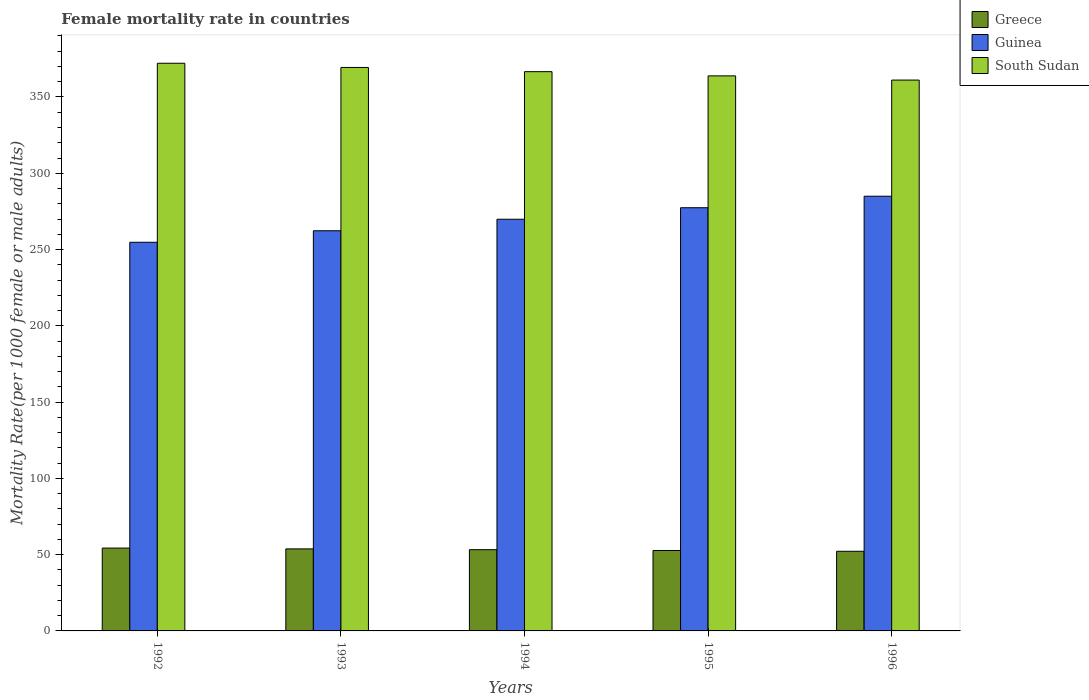Are the number of bars per tick equal to the number of legend labels?
Keep it short and to the point. Yes. Are the number of bars on each tick of the X-axis equal?
Offer a terse response. Yes. How many bars are there on the 2nd tick from the right?
Provide a short and direct response. 3. What is the label of the 3rd group of bars from the left?
Provide a succinct answer. 1994. What is the female mortality rate in Guinea in 1994?
Your response must be concise. 269.85. Across all years, what is the maximum female mortality rate in South Sudan?
Offer a terse response. 372.11. Across all years, what is the minimum female mortality rate in Guinea?
Your answer should be very brief. 254.76. What is the total female mortality rate in South Sudan in the graph?
Ensure brevity in your answer.  1832.97. What is the difference between the female mortality rate in Greece in 1994 and that in 1996?
Give a very brief answer. 1.05. What is the difference between the female mortality rate in South Sudan in 1994 and the female mortality rate in Guinea in 1995?
Your answer should be compact. 89.19. What is the average female mortality rate in Guinea per year?
Offer a terse response. 269.85. In the year 1994, what is the difference between the female mortality rate in Greece and female mortality rate in South Sudan?
Keep it short and to the point. -313.34. In how many years, is the female mortality rate in Greece greater than 310?
Your answer should be compact. 0. What is the ratio of the female mortality rate in Greece in 1993 to that in 1994?
Provide a succinct answer. 1.01. Is the female mortality rate in Guinea in 1993 less than that in 1995?
Make the answer very short. Yes. What is the difference between the highest and the second highest female mortality rate in South Sudan?
Ensure brevity in your answer.  2.76. What is the difference between the highest and the lowest female mortality rate in Greece?
Ensure brevity in your answer.  2.1. In how many years, is the female mortality rate in South Sudan greater than the average female mortality rate in South Sudan taken over all years?
Offer a terse response. 3. Is the sum of the female mortality rate in South Sudan in 1993 and 1996 greater than the maximum female mortality rate in Guinea across all years?
Your answer should be very brief. Yes. What does the 2nd bar from the left in 1992 represents?
Give a very brief answer. Guinea. What does the 3rd bar from the right in 1995 represents?
Make the answer very short. Greece. How many bars are there?
Your response must be concise. 15. Are all the bars in the graph horizontal?
Offer a terse response. No. How many years are there in the graph?
Make the answer very short. 5. What is the difference between two consecutive major ticks on the Y-axis?
Your answer should be very brief. 50. Where does the legend appear in the graph?
Offer a very short reply. Top right. What is the title of the graph?
Your response must be concise. Female mortality rate in countries. Does "Ethiopia" appear as one of the legend labels in the graph?
Keep it short and to the point. No. What is the label or title of the X-axis?
Your answer should be compact. Years. What is the label or title of the Y-axis?
Your answer should be very brief. Mortality Rate(per 1000 female or male adults). What is the Mortality Rate(per 1000 female or male adults) in Greece in 1992?
Your response must be concise. 54.31. What is the Mortality Rate(per 1000 female or male adults) of Guinea in 1992?
Your response must be concise. 254.76. What is the Mortality Rate(per 1000 female or male adults) of South Sudan in 1992?
Ensure brevity in your answer.  372.11. What is the Mortality Rate(per 1000 female or male adults) in Greece in 1993?
Make the answer very short. 53.78. What is the Mortality Rate(per 1000 female or male adults) of Guinea in 1993?
Provide a short and direct response. 262.31. What is the Mortality Rate(per 1000 female or male adults) in South Sudan in 1993?
Your response must be concise. 369.35. What is the Mortality Rate(per 1000 female or male adults) in Greece in 1994?
Provide a short and direct response. 53.26. What is the Mortality Rate(per 1000 female or male adults) of Guinea in 1994?
Ensure brevity in your answer.  269.85. What is the Mortality Rate(per 1000 female or male adults) in South Sudan in 1994?
Your answer should be very brief. 366.59. What is the Mortality Rate(per 1000 female or male adults) in Greece in 1995?
Your answer should be very brief. 52.73. What is the Mortality Rate(per 1000 female or male adults) in Guinea in 1995?
Your answer should be very brief. 277.4. What is the Mortality Rate(per 1000 female or male adults) in South Sudan in 1995?
Your response must be concise. 363.84. What is the Mortality Rate(per 1000 female or male adults) of Greece in 1996?
Your answer should be very brief. 52.21. What is the Mortality Rate(per 1000 female or male adults) of Guinea in 1996?
Your answer should be very brief. 284.95. What is the Mortality Rate(per 1000 female or male adults) of South Sudan in 1996?
Your response must be concise. 361.08. Across all years, what is the maximum Mortality Rate(per 1000 female or male adults) of Greece?
Keep it short and to the point. 54.31. Across all years, what is the maximum Mortality Rate(per 1000 female or male adults) of Guinea?
Make the answer very short. 284.95. Across all years, what is the maximum Mortality Rate(per 1000 female or male adults) in South Sudan?
Ensure brevity in your answer.  372.11. Across all years, what is the minimum Mortality Rate(per 1000 female or male adults) of Greece?
Your answer should be compact. 52.21. Across all years, what is the minimum Mortality Rate(per 1000 female or male adults) of Guinea?
Offer a very short reply. 254.76. Across all years, what is the minimum Mortality Rate(per 1000 female or male adults) in South Sudan?
Your response must be concise. 361.08. What is the total Mortality Rate(per 1000 female or male adults) in Greece in the graph?
Offer a terse response. 266.28. What is the total Mortality Rate(per 1000 female or male adults) of Guinea in the graph?
Keep it short and to the point. 1349.27. What is the total Mortality Rate(per 1000 female or male adults) in South Sudan in the graph?
Ensure brevity in your answer.  1832.97. What is the difference between the Mortality Rate(per 1000 female or male adults) in Greece in 1992 and that in 1993?
Keep it short and to the point. 0.53. What is the difference between the Mortality Rate(per 1000 female or male adults) in Guinea in 1992 and that in 1993?
Your answer should be compact. -7.55. What is the difference between the Mortality Rate(per 1000 female or male adults) in South Sudan in 1992 and that in 1993?
Keep it short and to the point. 2.76. What is the difference between the Mortality Rate(per 1000 female or male adults) of Greece in 1992 and that in 1994?
Give a very brief answer. 1.05. What is the difference between the Mortality Rate(per 1000 female or male adults) of Guinea in 1992 and that in 1994?
Your answer should be compact. -15.1. What is the difference between the Mortality Rate(per 1000 female or male adults) of South Sudan in 1992 and that in 1994?
Your response must be concise. 5.51. What is the difference between the Mortality Rate(per 1000 female or male adults) in Greece in 1992 and that in 1995?
Make the answer very short. 1.57. What is the difference between the Mortality Rate(per 1000 female or male adults) in Guinea in 1992 and that in 1995?
Offer a terse response. -22.65. What is the difference between the Mortality Rate(per 1000 female or male adults) in South Sudan in 1992 and that in 1995?
Your response must be concise. 8.27. What is the difference between the Mortality Rate(per 1000 female or male adults) in Greece in 1992 and that in 1996?
Keep it short and to the point. 2.1. What is the difference between the Mortality Rate(per 1000 female or male adults) of Guinea in 1992 and that in 1996?
Your response must be concise. -30.19. What is the difference between the Mortality Rate(per 1000 female or male adults) in South Sudan in 1992 and that in 1996?
Provide a short and direct response. 11.02. What is the difference between the Mortality Rate(per 1000 female or male adults) in Greece in 1993 and that in 1994?
Ensure brevity in your answer.  0.53. What is the difference between the Mortality Rate(per 1000 female or male adults) of Guinea in 1993 and that in 1994?
Offer a terse response. -7.55. What is the difference between the Mortality Rate(per 1000 female or male adults) in South Sudan in 1993 and that in 1994?
Provide a succinct answer. 2.76. What is the difference between the Mortality Rate(per 1000 female or male adults) in Greece in 1993 and that in 1995?
Make the answer very short. 1.05. What is the difference between the Mortality Rate(per 1000 female or male adults) of Guinea in 1993 and that in 1995?
Offer a terse response. -15.1. What is the difference between the Mortality Rate(per 1000 female or male adults) of South Sudan in 1993 and that in 1995?
Your response must be concise. 5.51. What is the difference between the Mortality Rate(per 1000 female or male adults) in Greece in 1993 and that in 1996?
Your answer should be compact. 1.57. What is the difference between the Mortality Rate(per 1000 female or male adults) of Guinea in 1993 and that in 1996?
Offer a very short reply. -22.64. What is the difference between the Mortality Rate(per 1000 female or male adults) of South Sudan in 1993 and that in 1996?
Make the answer very short. 8.27. What is the difference between the Mortality Rate(per 1000 female or male adults) in Greece in 1994 and that in 1995?
Your answer should be compact. 0.53. What is the difference between the Mortality Rate(per 1000 female or male adults) in Guinea in 1994 and that in 1995?
Your answer should be compact. -7.55. What is the difference between the Mortality Rate(per 1000 female or male adults) of South Sudan in 1994 and that in 1995?
Your answer should be compact. 2.76. What is the difference between the Mortality Rate(per 1000 female or male adults) in Greece in 1994 and that in 1996?
Give a very brief answer. 1.05. What is the difference between the Mortality Rate(per 1000 female or male adults) in Guinea in 1994 and that in 1996?
Your answer should be very brief. -15.1. What is the difference between the Mortality Rate(per 1000 female or male adults) in South Sudan in 1994 and that in 1996?
Keep it short and to the point. 5.51. What is the difference between the Mortality Rate(per 1000 female or male adults) of Greece in 1995 and that in 1996?
Provide a succinct answer. 0.53. What is the difference between the Mortality Rate(per 1000 female or male adults) in Guinea in 1995 and that in 1996?
Keep it short and to the point. -7.55. What is the difference between the Mortality Rate(per 1000 female or male adults) of South Sudan in 1995 and that in 1996?
Offer a terse response. 2.76. What is the difference between the Mortality Rate(per 1000 female or male adults) in Greece in 1992 and the Mortality Rate(per 1000 female or male adults) in Guinea in 1993?
Ensure brevity in your answer.  -208. What is the difference between the Mortality Rate(per 1000 female or male adults) of Greece in 1992 and the Mortality Rate(per 1000 female or male adults) of South Sudan in 1993?
Ensure brevity in your answer.  -315.04. What is the difference between the Mortality Rate(per 1000 female or male adults) in Guinea in 1992 and the Mortality Rate(per 1000 female or male adults) in South Sudan in 1993?
Your answer should be compact. -114.59. What is the difference between the Mortality Rate(per 1000 female or male adults) in Greece in 1992 and the Mortality Rate(per 1000 female or male adults) in Guinea in 1994?
Make the answer very short. -215.55. What is the difference between the Mortality Rate(per 1000 female or male adults) in Greece in 1992 and the Mortality Rate(per 1000 female or male adults) in South Sudan in 1994?
Offer a very short reply. -312.29. What is the difference between the Mortality Rate(per 1000 female or male adults) of Guinea in 1992 and the Mortality Rate(per 1000 female or male adults) of South Sudan in 1994?
Ensure brevity in your answer.  -111.84. What is the difference between the Mortality Rate(per 1000 female or male adults) in Greece in 1992 and the Mortality Rate(per 1000 female or male adults) in Guinea in 1995?
Your answer should be compact. -223.1. What is the difference between the Mortality Rate(per 1000 female or male adults) of Greece in 1992 and the Mortality Rate(per 1000 female or male adults) of South Sudan in 1995?
Offer a terse response. -309.53. What is the difference between the Mortality Rate(per 1000 female or male adults) of Guinea in 1992 and the Mortality Rate(per 1000 female or male adults) of South Sudan in 1995?
Your response must be concise. -109.08. What is the difference between the Mortality Rate(per 1000 female or male adults) of Greece in 1992 and the Mortality Rate(per 1000 female or male adults) of Guinea in 1996?
Provide a succinct answer. -230.64. What is the difference between the Mortality Rate(per 1000 female or male adults) in Greece in 1992 and the Mortality Rate(per 1000 female or male adults) in South Sudan in 1996?
Provide a succinct answer. -306.78. What is the difference between the Mortality Rate(per 1000 female or male adults) of Guinea in 1992 and the Mortality Rate(per 1000 female or male adults) of South Sudan in 1996?
Your answer should be very brief. -106.33. What is the difference between the Mortality Rate(per 1000 female or male adults) in Greece in 1993 and the Mortality Rate(per 1000 female or male adults) in Guinea in 1994?
Offer a very short reply. -216.07. What is the difference between the Mortality Rate(per 1000 female or male adults) of Greece in 1993 and the Mortality Rate(per 1000 female or male adults) of South Sudan in 1994?
Your answer should be compact. -312.81. What is the difference between the Mortality Rate(per 1000 female or male adults) of Guinea in 1993 and the Mortality Rate(per 1000 female or male adults) of South Sudan in 1994?
Ensure brevity in your answer.  -104.29. What is the difference between the Mortality Rate(per 1000 female or male adults) of Greece in 1993 and the Mortality Rate(per 1000 female or male adults) of Guinea in 1995?
Your response must be concise. -223.62. What is the difference between the Mortality Rate(per 1000 female or male adults) of Greece in 1993 and the Mortality Rate(per 1000 female or male adults) of South Sudan in 1995?
Keep it short and to the point. -310.06. What is the difference between the Mortality Rate(per 1000 female or male adults) of Guinea in 1993 and the Mortality Rate(per 1000 female or male adults) of South Sudan in 1995?
Keep it short and to the point. -101.53. What is the difference between the Mortality Rate(per 1000 female or male adults) in Greece in 1993 and the Mortality Rate(per 1000 female or male adults) in Guinea in 1996?
Make the answer very short. -231.17. What is the difference between the Mortality Rate(per 1000 female or male adults) of Greece in 1993 and the Mortality Rate(per 1000 female or male adults) of South Sudan in 1996?
Provide a short and direct response. -307.3. What is the difference between the Mortality Rate(per 1000 female or male adults) of Guinea in 1993 and the Mortality Rate(per 1000 female or male adults) of South Sudan in 1996?
Offer a very short reply. -98.78. What is the difference between the Mortality Rate(per 1000 female or male adults) in Greece in 1994 and the Mortality Rate(per 1000 female or male adults) in Guinea in 1995?
Keep it short and to the point. -224.15. What is the difference between the Mortality Rate(per 1000 female or male adults) of Greece in 1994 and the Mortality Rate(per 1000 female or male adults) of South Sudan in 1995?
Provide a succinct answer. -310.58. What is the difference between the Mortality Rate(per 1000 female or male adults) of Guinea in 1994 and the Mortality Rate(per 1000 female or male adults) of South Sudan in 1995?
Give a very brief answer. -93.98. What is the difference between the Mortality Rate(per 1000 female or male adults) in Greece in 1994 and the Mortality Rate(per 1000 female or male adults) in Guinea in 1996?
Ensure brevity in your answer.  -231.69. What is the difference between the Mortality Rate(per 1000 female or male adults) in Greece in 1994 and the Mortality Rate(per 1000 female or male adults) in South Sudan in 1996?
Your answer should be compact. -307.83. What is the difference between the Mortality Rate(per 1000 female or male adults) in Guinea in 1994 and the Mortality Rate(per 1000 female or male adults) in South Sudan in 1996?
Offer a very short reply. -91.23. What is the difference between the Mortality Rate(per 1000 female or male adults) in Greece in 1995 and the Mortality Rate(per 1000 female or male adults) in Guinea in 1996?
Ensure brevity in your answer.  -232.22. What is the difference between the Mortality Rate(per 1000 female or male adults) of Greece in 1995 and the Mortality Rate(per 1000 female or male adults) of South Sudan in 1996?
Make the answer very short. -308.35. What is the difference between the Mortality Rate(per 1000 female or male adults) in Guinea in 1995 and the Mortality Rate(per 1000 female or male adults) in South Sudan in 1996?
Your answer should be very brief. -83.68. What is the average Mortality Rate(per 1000 female or male adults) of Greece per year?
Keep it short and to the point. 53.26. What is the average Mortality Rate(per 1000 female or male adults) in Guinea per year?
Your answer should be very brief. 269.85. What is the average Mortality Rate(per 1000 female or male adults) of South Sudan per year?
Make the answer very short. 366.59. In the year 1992, what is the difference between the Mortality Rate(per 1000 female or male adults) of Greece and Mortality Rate(per 1000 female or male adults) of Guinea?
Give a very brief answer. -200.45. In the year 1992, what is the difference between the Mortality Rate(per 1000 female or male adults) in Greece and Mortality Rate(per 1000 female or male adults) in South Sudan?
Your answer should be very brief. -317.8. In the year 1992, what is the difference between the Mortality Rate(per 1000 female or male adults) in Guinea and Mortality Rate(per 1000 female or male adults) in South Sudan?
Give a very brief answer. -117.35. In the year 1993, what is the difference between the Mortality Rate(per 1000 female or male adults) in Greece and Mortality Rate(per 1000 female or male adults) in Guinea?
Your response must be concise. -208.52. In the year 1993, what is the difference between the Mortality Rate(per 1000 female or male adults) in Greece and Mortality Rate(per 1000 female or male adults) in South Sudan?
Your answer should be compact. -315.57. In the year 1993, what is the difference between the Mortality Rate(per 1000 female or male adults) of Guinea and Mortality Rate(per 1000 female or male adults) of South Sudan?
Ensure brevity in your answer.  -107.05. In the year 1994, what is the difference between the Mortality Rate(per 1000 female or male adults) of Greece and Mortality Rate(per 1000 female or male adults) of Guinea?
Your answer should be compact. -216.6. In the year 1994, what is the difference between the Mortality Rate(per 1000 female or male adults) of Greece and Mortality Rate(per 1000 female or male adults) of South Sudan?
Keep it short and to the point. -313.34. In the year 1994, what is the difference between the Mortality Rate(per 1000 female or male adults) in Guinea and Mortality Rate(per 1000 female or male adults) in South Sudan?
Ensure brevity in your answer.  -96.74. In the year 1995, what is the difference between the Mortality Rate(per 1000 female or male adults) in Greece and Mortality Rate(per 1000 female or male adults) in Guinea?
Your response must be concise. -224.67. In the year 1995, what is the difference between the Mortality Rate(per 1000 female or male adults) in Greece and Mortality Rate(per 1000 female or male adults) in South Sudan?
Give a very brief answer. -311.11. In the year 1995, what is the difference between the Mortality Rate(per 1000 female or male adults) of Guinea and Mortality Rate(per 1000 female or male adults) of South Sudan?
Keep it short and to the point. -86.44. In the year 1996, what is the difference between the Mortality Rate(per 1000 female or male adults) of Greece and Mortality Rate(per 1000 female or male adults) of Guinea?
Keep it short and to the point. -232.74. In the year 1996, what is the difference between the Mortality Rate(per 1000 female or male adults) of Greece and Mortality Rate(per 1000 female or male adults) of South Sudan?
Ensure brevity in your answer.  -308.88. In the year 1996, what is the difference between the Mortality Rate(per 1000 female or male adults) of Guinea and Mortality Rate(per 1000 female or male adults) of South Sudan?
Ensure brevity in your answer.  -76.13. What is the ratio of the Mortality Rate(per 1000 female or male adults) of Greece in 1992 to that in 1993?
Make the answer very short. 1.01. What is the ratio of the Mortality Rate(per 1000 female or male adults) in Guinea in 1992 to that in 1993?
Your answer should be compact. 0.97. What is the ratio of the Mortality Rate(per 1000 female or male adults) in South Sudan in 1992 to that in 1993?
Provide a succinct answer. 1.01. What is the ratio of the Mortality Rate(per 1000 female or male adults) in Greece in 1992 to that in 1994?
Make the answer very short. 1.02. What is the ratio of the Mortality Rate(per 1000 female or male adults) in Guinea in 1992 to that in 1994?
Your answer should be very brief. 0.94. What is the ratio of the Mortality Rate(per 1000 female or male adults) in Greece in 1992 to that in 1995?
Your answer should be compact. 1.03. What is the ratio of the Mortality Rate(per 1000 female or male adults) in Guinea in 1992 to that in 1995?
Your response must be concise. 0.92. What is the ratio of the Mortality Rate(per 1000 female or male adults) in South Sudan in 1992 to that in 1995?
Make the answer very short. 1.02. What is the ratio of the Mortality Rate(per 1000 female or male adults) of Greece in 1992 to that in 1996?
Make the answer very short. 1.04. What is the ratio of the Mortality Rate(per 1000 female or male adults) of Guinea in 1992 to that in 1996?
Provide a succinct answer. 0.89. What is the ratio of the Mortality Rate(per 1000 female or male adults) in South Sudan in 1992 to that in 1996?
Offer a very short reply. 1.03. What is the ratio of the Mortality Rate(per 1000 female or male adults) in Greece in 1993 to that in 1994?
Keep it short and to the point. 1.01. What is the ratio of the Mortality Rate(per 1000 female or male adults) of South Sudan in 1993 to that in 1994?
Your response must be concise. 1.01. What is the ratio of the Mortality Rate(per 1000 female or male adults) of Greece in 1993 to that in 1995?
Your response must be concise. 1.02. What is the ratio of the Mortality Rate(per 1000 female or male adults) in Guinea in 1993 to that in 1995?
Keep it short and to the point. 0.95. What is the ratio of the Mortality Rate(per 1000 female or male adults) in South Sudan in 1993 to that in 1995?
Provide a succinct answer. 1.02. What is the ratio of the Mortality Rate(per 1000 female or male adults) in Greece in 1993 to that in 1996?
Give a very brief answer. 1.03. What is the ratio of the Mortality Rate(per 1000 female or male adults) in Guinea in 1993 to that in 1996?
Provide a short and direct response. 0.92. What is the ratio of the Mortality Rate(per 1000 female or male adults) of South Sudan in 1993 to that in 1996?
Provide a short and direct response. 1.02. What is the ratio of the Mortality Rate(per 1000 female or male adults) in Greece in 1994 to that in 1995?
Offer a terse response. 1.01. What is the ratio of the Mortality Rate(per 1000 female or male adults) in Guinea in 1994 to that in 1995?
Your answer should be compact. 0.97. What is the ratio of the Mortality Rate(per 1000 female or male adults) in South Sudan in 1994 to that in 1995?
Your response must be concise. 1.01. What is the ratio of the Mortality Rate(per 1000 female or male adults) in Greece in 1994 to that in 1996?
Ensure brevity in your answer.  1.02. What is the ratio of the Mortality Rate(per 1000 female or male adults) in Guinea in 1994 to that in 1996?
Offer a very short reply. 0.95. What is the ratio of the Mortality Rate(per 1000 female or male adults) in South Sudan in 1994 to that in 1996?
Your response must be concise. 1.02. What is the ratio of the Mortality Rate(per 1000 female or male adults) of Guinea in 1995 to that in 1996?
Make the answer very short. 0.97. What is the ratio of the Mortality Rate(per 1000 female or male adults) of South Sudan in 1995 to that in 1996?
Your answer should be very brief. 1.01. What is the difference between the highest and the second highest Mortality Rate(per 1000 female or male adults) in Greece?
Make the answer very short. 0.53. What is the difference between the highest and the second highest Mortality Rate(per 1000 female or male adults) in Guinea?
Keep it short and to the point. 7.55. What is the difference between the highest and the second highest Mortality Rate(per 1000 female or male adults) of South Sudan?
Provide a succinct answer. 2.76. What is the difference between the highest and the lowest Mortality Rate(per 1000 female or male adults) in Greece?
Your response must be concise. 2.1. What is the difference between the highest and the lowest Mortality Rate(per 1000 female or male adults) of Guinea?
Keep it short and to the point. 30.19. What is the difference between the highest and the lowest Mortality Rate(per 1000 female or male adults) of South Sudan?
Your response must be concise. 11.02. 